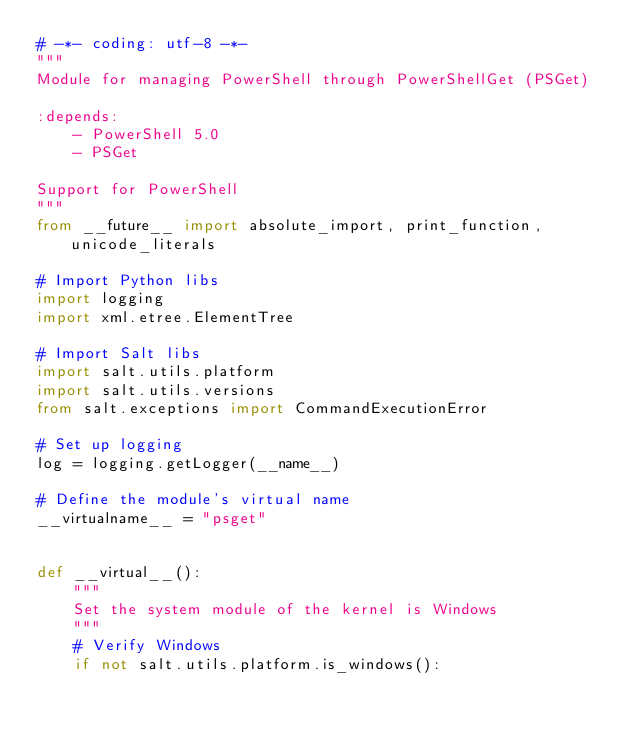<code> <loc_0><loc_0><loc_500><loc_500><_Python_># -*- coding: utf-8 -*-
"""
Module for managing PowerShell through PowerShellGet (PSGet)

:depends:
    - PowerShell 5.0
    - PSGet

Support for PowerShell
"""
from __future__ import absolute_import, print_function, unicode_literals

# Import Python libs
import logging
import xml.etree.ElementTree

# Import Salt libs
import salt.utils.platform
import salt.utils.versions
from salt.exceptions import CommandExecutionError

# Set up logging
log = logging.getLogger(__name__)

# Define the module's virtual name
__virtualname__ = "psget"


def __virtual__():
    """
    Set the system module of the kernel is Windows
    """
    # Verify Windows
    if not salt.utils.platform.is_windows():</code> 